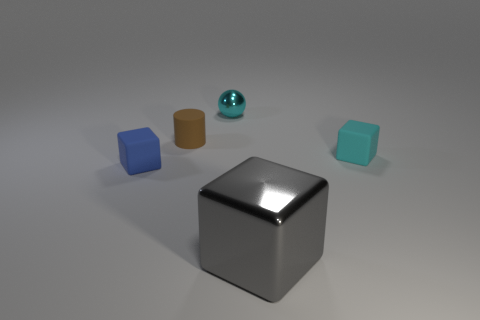Is there anything else that has the same size as the gray thing?
Your answer should be very brief. No. Are there any small cyan things made of the same material as the big thing?
Provide a short and direct response. Yes. There is a rubber cube that is on the left side of the rubber block that is behind the block that is left of the big gray cube; what color is it?
Provide a short and direct response. Blue. There is a metal object that is behind the gray metallic thing; is it the same color as the object right of the big cube?
Offer a very short reply. Yes. Is there any other thing that is the same color as the sphere?
Make the answer very short. Yes. Is the number of tiny rubber blocks that are behind the tiny brown matte object less than the number of small brown matte cylinders?
Offer a very short reply. Yes. What number of tiny cyan rubber objects are there?
Give a very brief answer. 1. Is the shape of the small cyan metallic thing the same as the matte object that is to the right of the small shiny ball?
Your response must be concise. No. Are there fewer small blue matte cubes that are on the right side of the brown matte thing than matte objects that are left of the tiny cyan metallic thing?
Give a very brief answer. Yes. Are there any other things that have the same shape as the small metal thing?
Offer a terse response. No. 